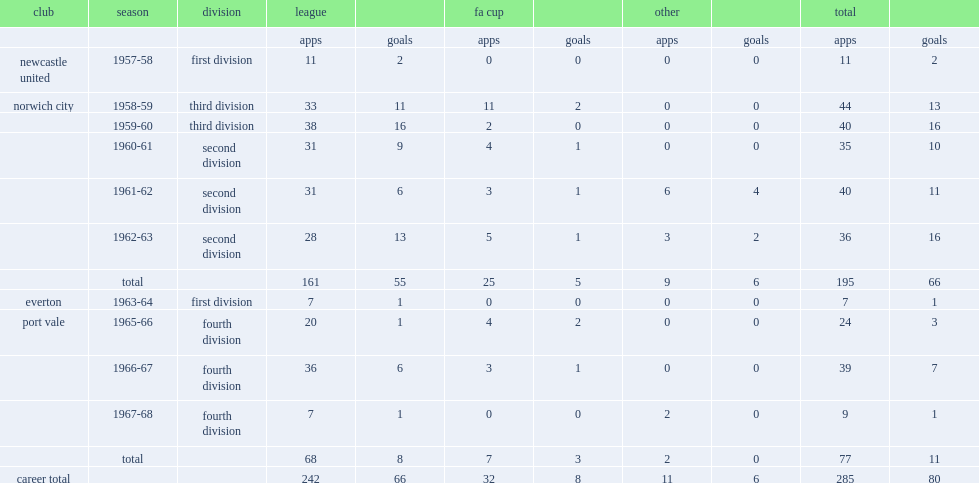Which division did jimmy hill participate in norwich city during 1959-60? Third division. 